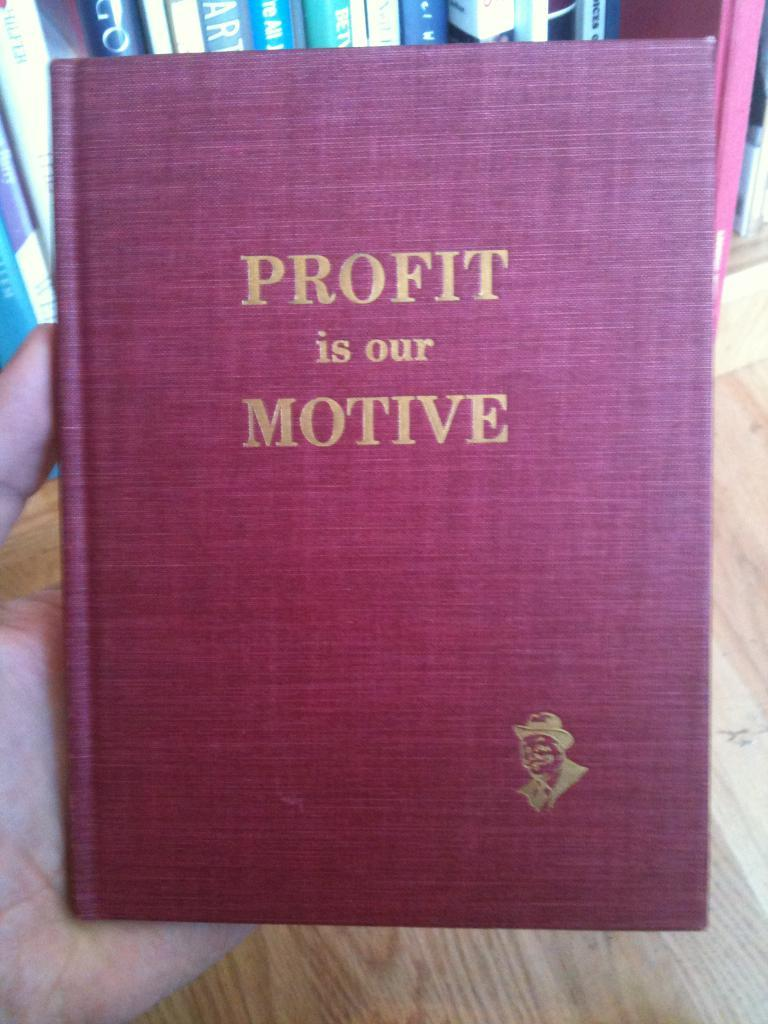<image>
Summarize the visual content of the image. A hand holds a book proclaiming "Profit is our motive. 